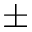Convert formula to latex. <formula><loc_0><loc_0><loc_500><loc_500>\pm</formula> 